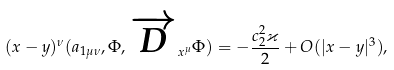<formula> <loc_0><loc_0><loc_500><loc_500>( x - y ) ^ { \nu } ( a _ { 1 \mu \nu } , \Phi , \overrightarrow { D } _ { x ^ { \mu } } \Phi ) = - \frac { c ^ { 2 } _ { 2 } \varkappa } { 2 } + O ( | x - y | ^ { 3 } ) ,</formula> 